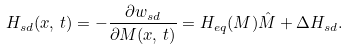<formula> <loc_0><loc_0><loc_500><loc_500>H _ { s d } ( x , \, t ) = - \frac { \partial w _ { s d } } { \partial M ( x , \, t ) } = H _ { e q } ( M ) \hat { M } + \Delta H _ { s d } .</formula> 